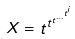<formula> <loc_0><loc_0><loc_500><loc_500>X = t ^ { t ^ { t ^ { \dots ^ { t ^ { i } } } } }</formula> 